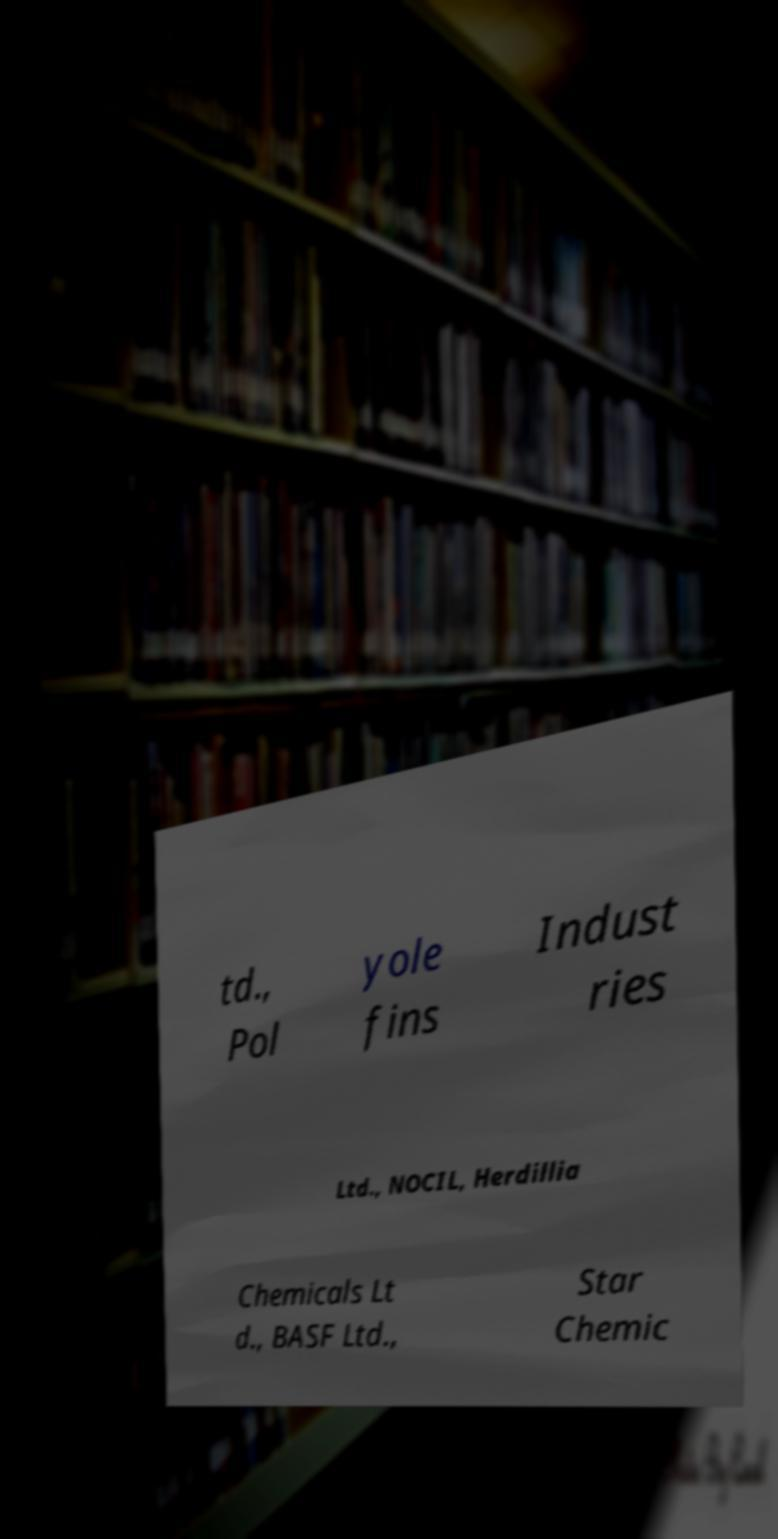There's text embedded in this image that I need extracted. Can you transcribe it verbatim? td., Pol yole fins Indust ries Ltd., NOCIL, Herdillia Chemicals Lt d., BASF Ltd., Star Chemic 